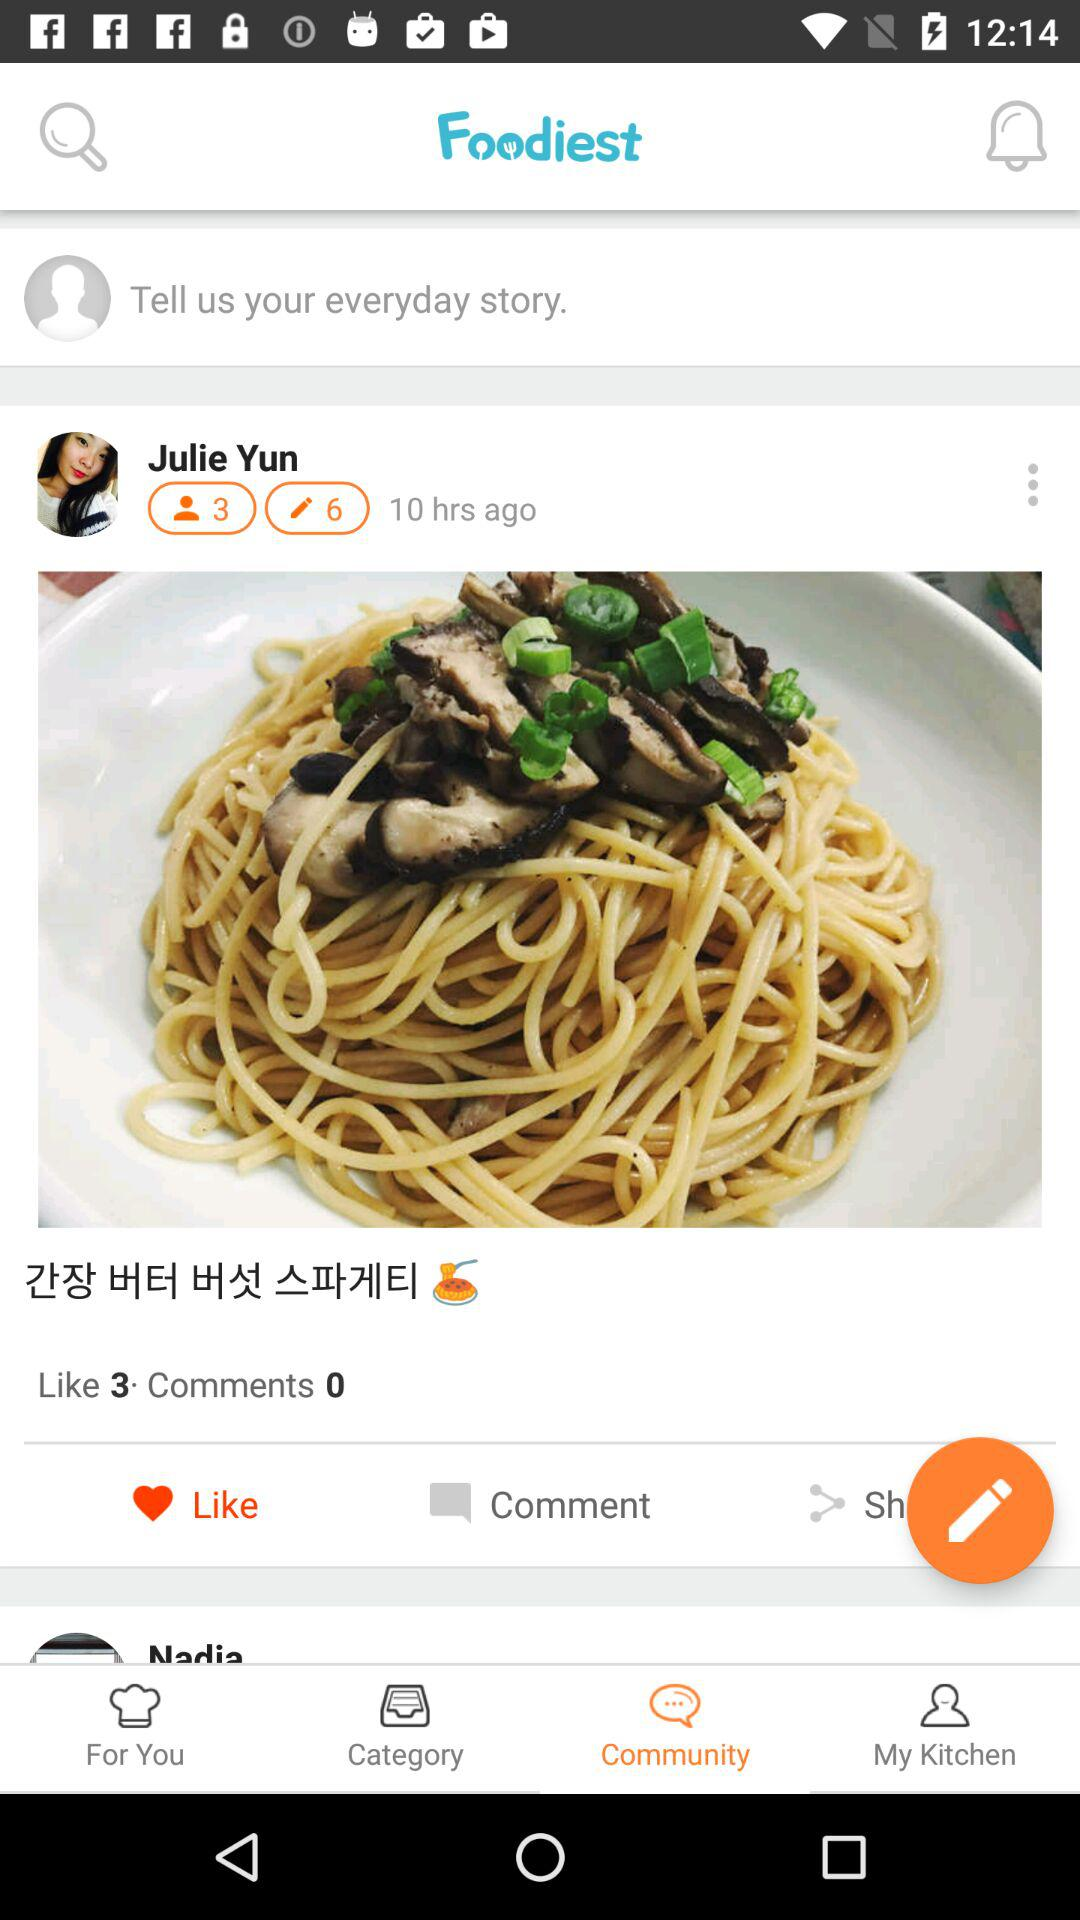How long ago was this post made?
Answer the question using a single word or phrase. 10 hrs ago 